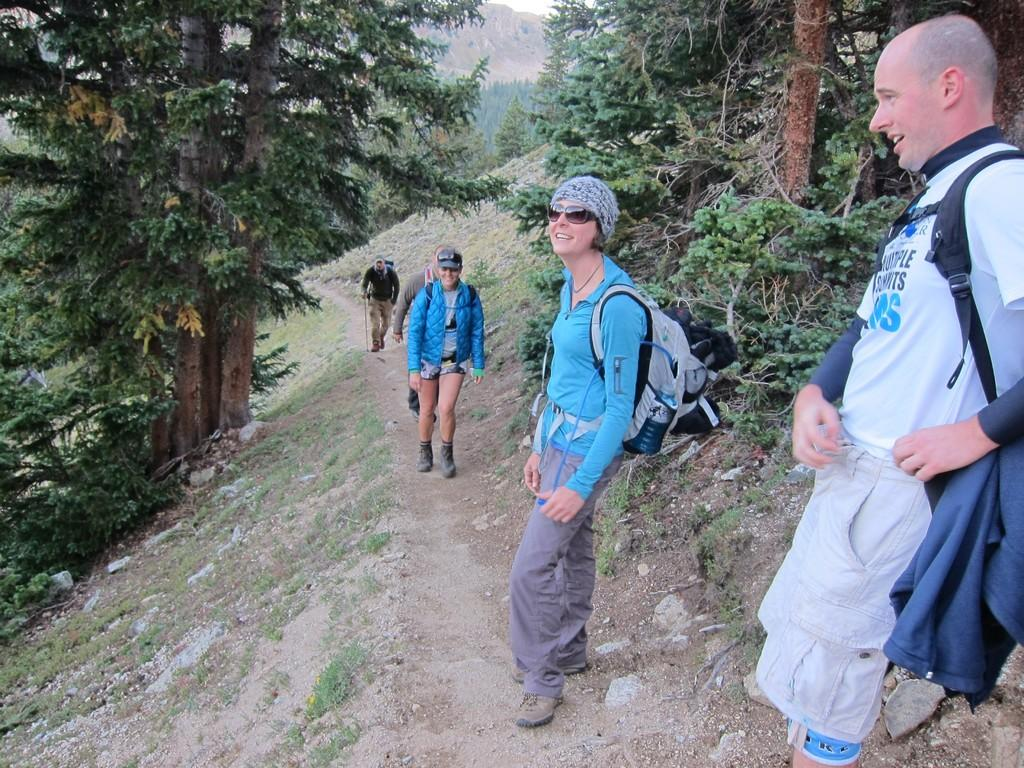Who or what can be seen in the image? There are people in the image. What is the surface beneath the people's feet? The ground is visible in the image. What type of objects are present on the ground? There are stones and grass on the ground. What type of vegetation is present in the image? There are trees and plants in the image. What can be seen in the distance in the image? There are mountains in the background of the image. What is visible above the people and the landscape? The sky is visible in the image. How many dimes can be seen on the ground in the image? There are no dimes visible on the ground in the image. What season is depicted in the image? The provided facts do not mention any specific season, so it cannot be determined from the image. 